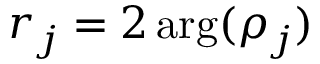Convert formula to latex. <formula><loc_0><loc_0><loc_500><loc_500>r _ { j } = 2 \arg ( \rho _ { j } )</formula> 